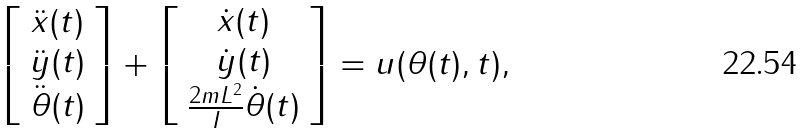Convert formula to latex. <formula><loc_0><loc_0><loc_500><loc_500>\left [ \begin{array} { c } \ddot { x } ( t ) \\ \ddot { y } ( t ) \\ \ddot { \theta } ( t ) \end{array} \right ] + \left [ \begin{array} { c } \dot { x } ( t ) \\ \dot { y } ( t ) \\ \frac { 2 m L ^ { 2 } } { I } \dot { \theta } ( t ) \end{array} \right ] = u ( \theta ( t ) , t ) ,</formula> 